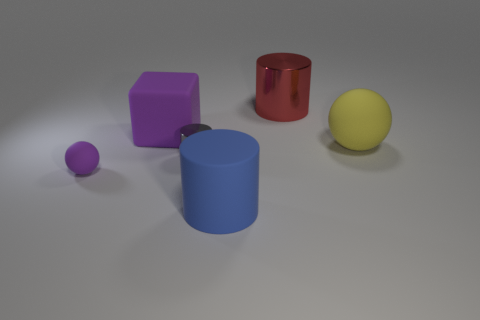Add 1 cyan metal cubes. How many objects exist? 7 Subtract all balls. How many objects are left? 4 Subtract all tiny rubber objects. Subtract all big blue matte cylinders. How many objects are left? 4 Add 4 yellow matte spheres. How many yellow matte spheres are left? 5 Add 3 large cyan metal blocks. How many large cyan metal blocks exist? 3 Subtract 0 green balls. How many objects are left? 6 